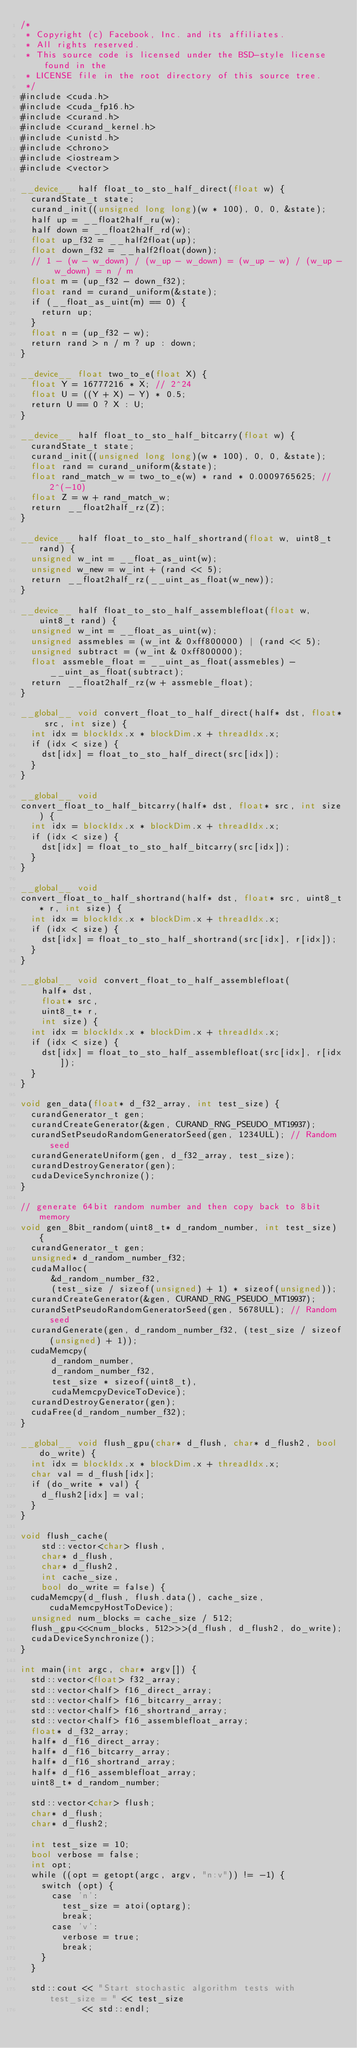<code> <loc_0><loc_0><loc_500><loc_500><_Cuda_>/*
 * Copyright (c) Facebook, Inc. and its affiliates.
 * All rights reserved.
 * This source code is licensed under the BSD-style license found in the
 * LICENSE file in the root directory of this source tree.
 */
#include <cuda.h>
#include <cuda_fp16.h>
#include <curand.h>
#include <curand_kernel.h>
#include <unistd.h>
#include <chrono>
#include <iostream>
#include <vector>

__device__ half float_to_sto_half_direct(float w) {
  curandState_t state;
  curand_init((unsigned long long)(w * 100), 0, 0, &state);
  half up = __float2half_ru(w);
  half down = __float2half_rd(w);
  float up_f32 = __half2float(up);
  float down_f32 = __half2float(down);
  // 1 - (w - w_down) / (w_up - w_down) = (w_up - w) / (w_up - w_down) = n / m
  float m = (up_f32 - down_f32);
  float rand = curand_uniform(&state);
  if (__float_as_uint(m) == 0) {
    return up;
  }
  float n = (up_f32 - w);
  return rand > n / m ? up : down;
}

__device__ float two_to_e(float X) {
  float Y = 16777216 * X; // 2^24
  float U = ((Y + X) - Y) * 0.5;
  return U == 0 ? X : U;
}

__device__ half float_to_sto_half_bitcarry(float w) {
  curandState_t state;
  curand_init((unsigned long long)(w * 100), 0, 0, &state);
  float rand = curand_uniform(&state);
  float rand_match_w = two_to_e(w) * rand * 0.0009765625; // 2^(-10)
  float Z = w + rand_match_w;
  return __float2half_rz(Z);
}

__device__ half float_to_sto_half_shortrand(float w, uint8_t rand) {
  unsigned w_int = __float_as_uint(w);
  unsigned w_new = w_int + (rand << 5);
  return __float2half_rz(__uint_as_float(w_new));
}

__device__ half float_to_sto_half_assemblefloat(float w, uint8_t rand) {
  unsigned w_int = __float_as_uint(w);
  unsigned assmebles = (w_int & 0xff800000) | (rand << 5);
  unsigned subtract = (w_int & 0xff800000);
  float assmeble_float = __uint_as_float(assmebles) - __uint_as_float(subtract);
  return __float2half_rz(w + assmeble_float);
}

__global__ void convert_float_to_half_direct(half* dst, float* src, int size) {
  int idx = blockIdx.x * blockDim.x + threadIdx.x;
  if (idx < size) {
    dst[idx] = float_to_sto_half_direct(src[idx]);
  }
}

__global__ void
convert_float_to_half_bitcarry(half* dst, float* src, int size) {
  int idx = blockIdx.x * blockDim.x + threadIdx.x;
  if (idx < size) {
    dst[idx] = float_to_sto_half_bitcarry(src[idx]);
  }
}

__global__ void
convert_float_to_half_shortrand(half* dst, float* src, uint8_t* r, int size) {
  int idx = blockIdx.x * blockDim.x + threadIdx.x;
  if (idx < size) {
    dst[idx] = float_to_sto_half_shortrand(src[idx], r[idx]);
  }
}

__global__ void convert_float_to_half_assemblefloat(
    half* dst,
    float* src,
    uint8_t* r,
    int size) {
  int idx = blockIdx.x * blockDim.x + threadIdx.x;
  if (idx < size) {
    dst[idx] = float_to_sto_half_assemblefloat(src[idx], r[idx]);
  }
}

void gen_data(float* d_f32_array, int test_size) {
  curandGenerator_t gen;
  curandCreateGenerator(&gen, CURAND_RNG_PSEUDO_MT19937);
  curandSetPseudoRandomGeneratorSeed(gen, 1234ULL); // Random seed
  curandGenerateUniform(gen, d_f32_array, test_size);
  curandDestroyGenerator(gen);
  cudaDeviceSynchronize();
}

// generate 64bit random number and then copy back to 8bit memory
void gen_8bit_random(uint8_t* d_random_number, int test_size) {
  curandGenerator_t gen;
  unsigned* d_random_number_f32;
  cudaMalloc(
      &d_random_number_f32,
      (test_size / sizeof(unsigned) + 1) * sizeof(unsigned));
  curandCreateGenerator(&gen, CURAND_RNG_PSEUDO_MT19937);
  curandSetPseudoRandomGeneratorSeed(gen, 5678ULL); // Random seed
  curandGenerate(gen, d_random_number_f32, (test_size / sizeof(unsigned) + 1));
  cudaMemcpy(
      d_random_number,
      d_random_number_f32,
      test_size * sizeof(uint8_t),
      cudaMemcpyDeviceToDevice);
  curandDestroyGenerator(gen);
  cudaFree(d_random_number_f32);
}

__global__ void flush_gpu(char* d_flush, char* d_flush2, bool do_write) {
  int idx = blockIdx.x * blockDim.x + threadIdx.x;
  char val = d_flush[idx];
  if (do_write * val) {
    d_flush2[idx] = val;
  }
}

void flush_cache(
    std::vector<char> flush,
    char* d_flush,
    char* d_flush2,
    int cache_size,
    bool do_write = false) {
  cudaMemcpy(d_flush, flush.data(), cache_size, cudaMemcpyHostToDevice);
  unsigned num_blocks = cache_size / 512;
  flush_gpu<<<num_blocks, 512>>>(d_flush, d_flush2, do_write);
  cudaDeviceSynchronize();
}

int main(int argc, char* argv[]) {
  std::vector<float> f32_array;
  std::vector<half> f16_direct_array;
  std::vector<half> f16_bitcarry_array;
  std::vector<half> f16_shortrand_array;
  std::vector<half> f16_assemblefloat_array;
  float* d_f32_array;
  half* d_f16_direct_array;
  half* d_f16_bitcarry_array;
  half* d_f16_shortrand_array;
  half* d_f16_assemblefloat_array;
  uint8_t* d_random_number;

  std::vector<char> flush;
  char* d_flush;
  char* d_flush2;

  int test_size = 10;
  bool verbose = false;
  int opt;
  while ((opt = getopt(argc, argv, "n:v")) != -1) {
    switch (opt) {
      case 'n':
        test_size = atoi(optarg);
        break;
      case 'v':
        verbose = true;
        break;
    }
  }

  std::cout << "Start stochastic algorithm tests with test_size = " << test_size
            << std::endl;</code> 